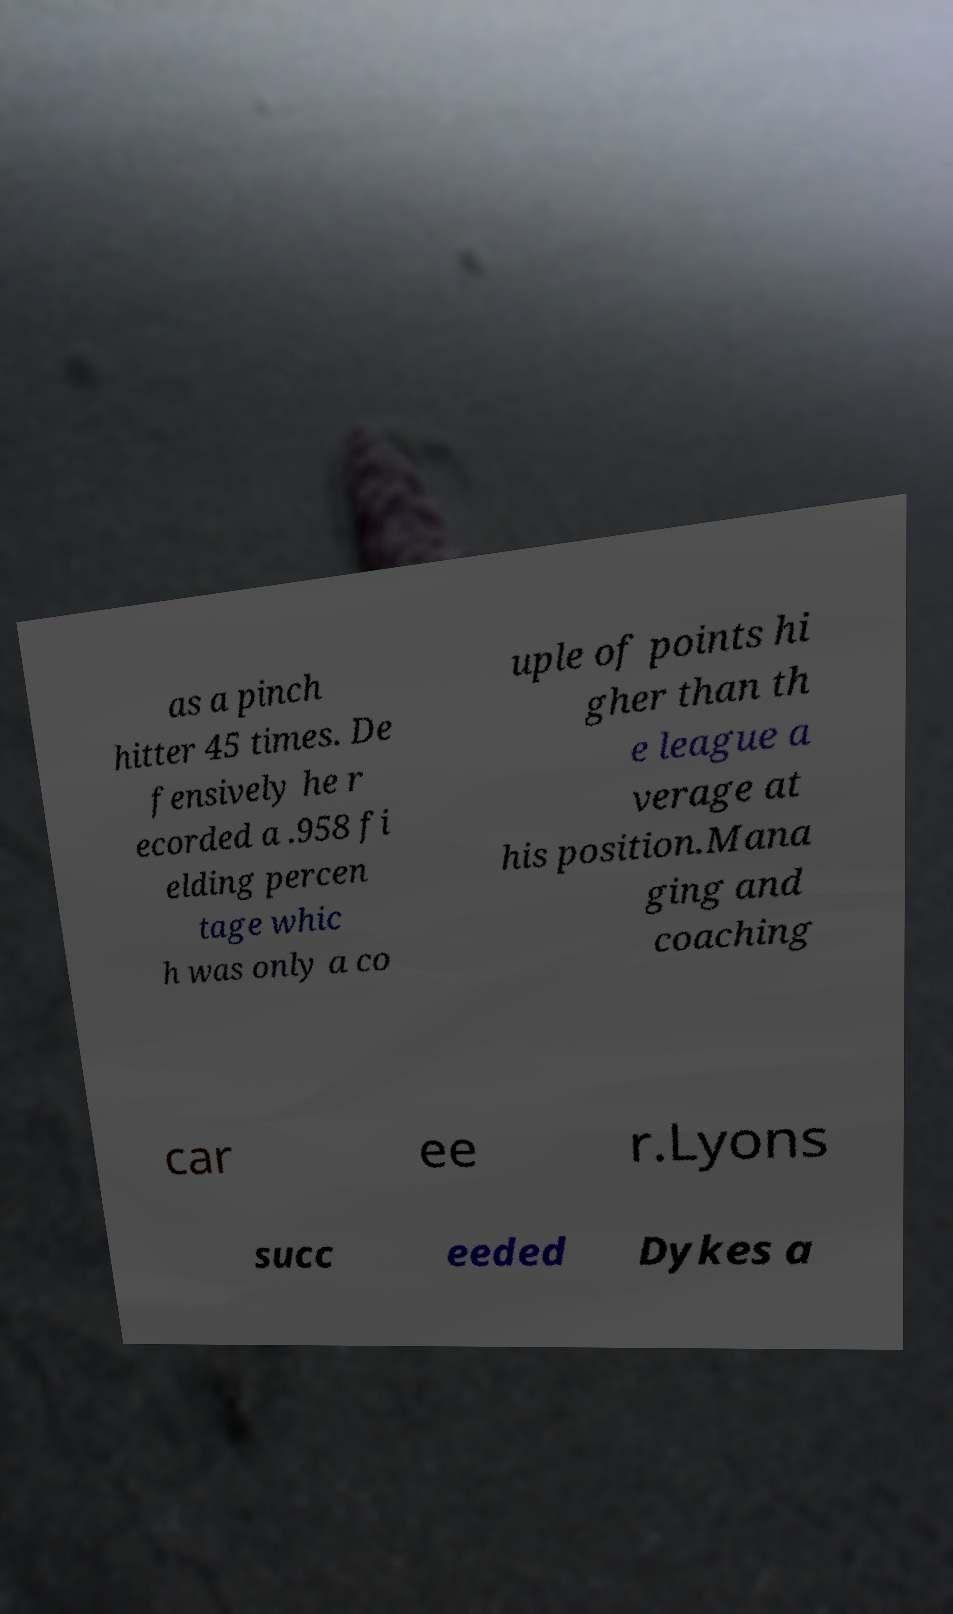Please identify and transcribe the text found in this image. as a pinch hitter 45 times. De fensively he r ecorded a .958 fi elding percen tage whic h was only a co uple of points hi gher than th e league a verage at his position.Mana ging and coaching car ee r.Lyons succ eeded Dykes a 